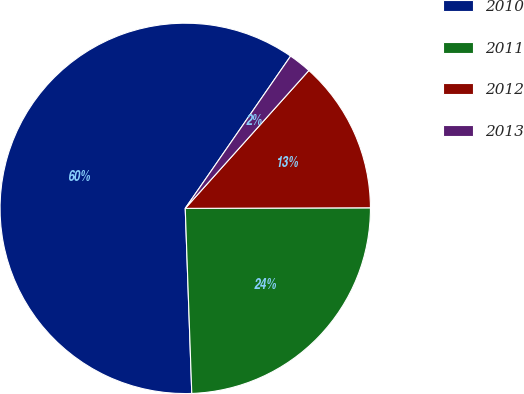<chart> <loc_0><loc_0><loc_500><loc_500><pie_chart><fcel>2010<fcel>2011<fcel>2012<fcel>2013<nl><fcel>60.2%<fcel>24.49%<fcel>13.32%<fcel>2.0%<nl></chart> 